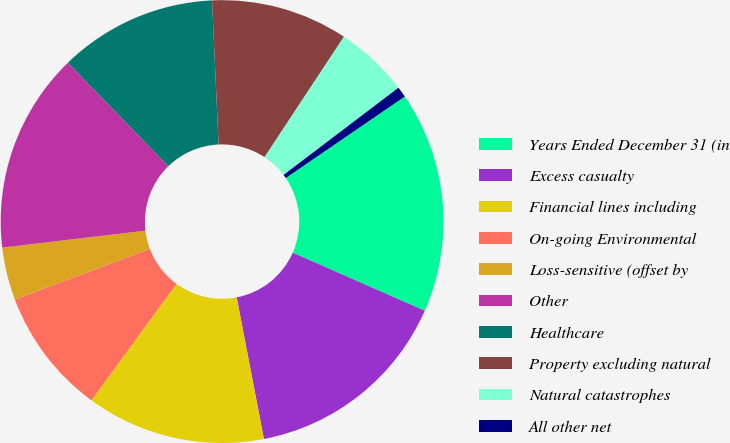Convert chart. <chart><loc_0><loc_0><loc_500><loc_500><pie_chart><fcel>Years Ended December 31 (in<fcel>Excess casualty<fcel>Financial lines including<fcel>On-going Environmental<fcel>Loss-sensitive (offset by<fcel>Other<fcel>Healthcare<fcel>Property excluding natural<fcel>Natural catastrophes<fcel>All other net<nl><fcel>16.15%<fcel>15.38%<fcel>13.07%<fcel>9.23%<fcel>3.85%<fcel>14.61%<fcel>11.54%<fcel>10.0%<fcel>5.39%<fcel>0.78%<nl></chart> 